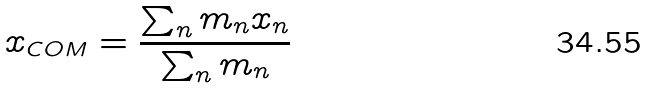<formula> <loc_0><loc_0><loc_500><loc_500>x _ { C O M } = { \frac { \sum _ { n } m _ { n } x _ { n } } { \sum _ { n } m _ { n } } }</formula> 